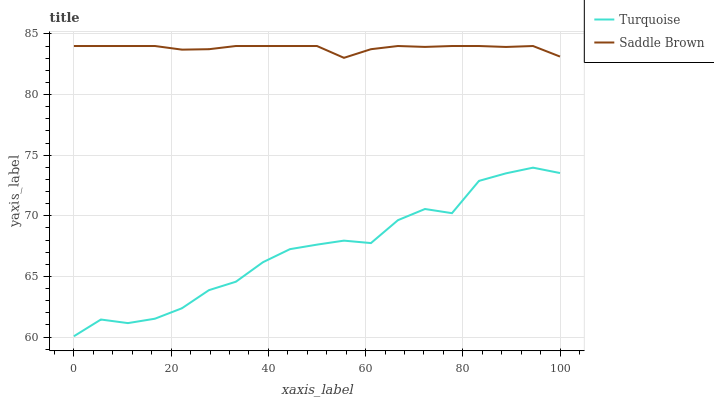Does Saddle Brown have the minimum area under the curve?
Answer yes or no. No. Is Saddle Brown the roughest?
Answer yes or no. No. Does Saddle Brown have the lowest value?
Answer yes or no. No. Is Turquoise less than Saddle Brown?
Answer yes or no. Yes. Is Saddle Brown greater than Turquoise?
Answer yes or no. Yes. Does Turquoise intersect Saddle Brown?
Answer yes or no. No. 